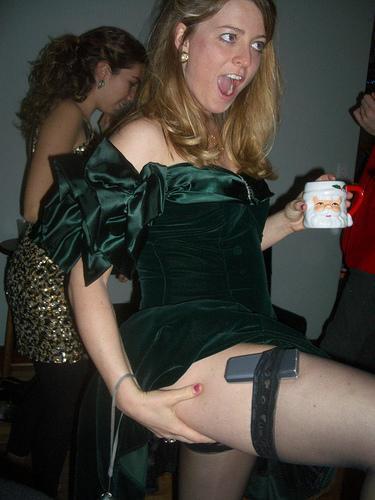How many people are in the picture?
Give a very brief answer. 3. 